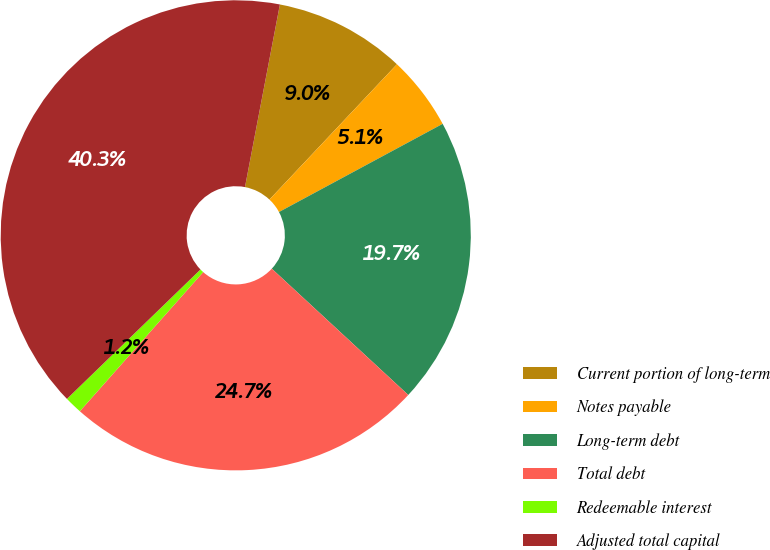Convert chart. <chart><loc_0><loc_0><loc_500><loc_500><pie_chart><fcel>Current portion of long-term<fcel>Notes payable<fcel>Long-term debt<fcel>Total debt<fcel>Redeemable interest<fcel>Adjusted total capital<nl><fcel>9.02%<fcel>5.11%<fcel>19.75%<fcel>24.66%<fcel>1.21%<fcel>40.26%<nl></chart> 